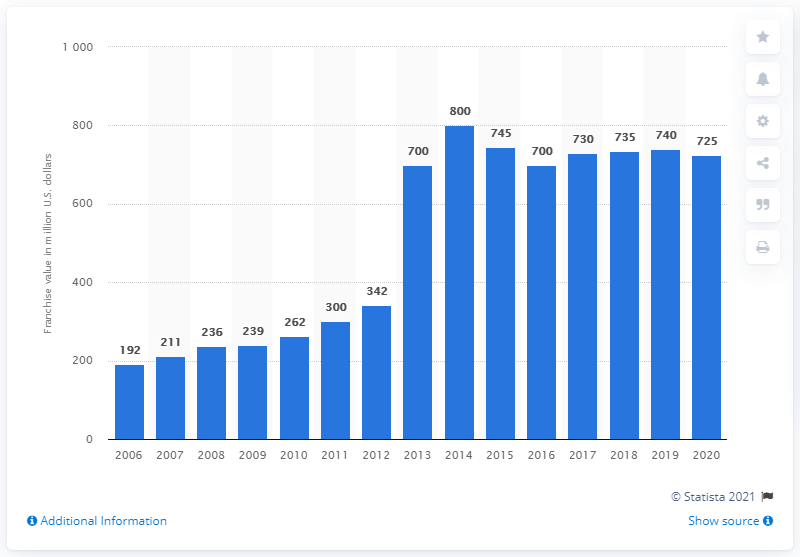Highlight a few significant elements in this photo. The value of the Vancouver Canucks franchise in 2020 was approximately 725 million dollars. 